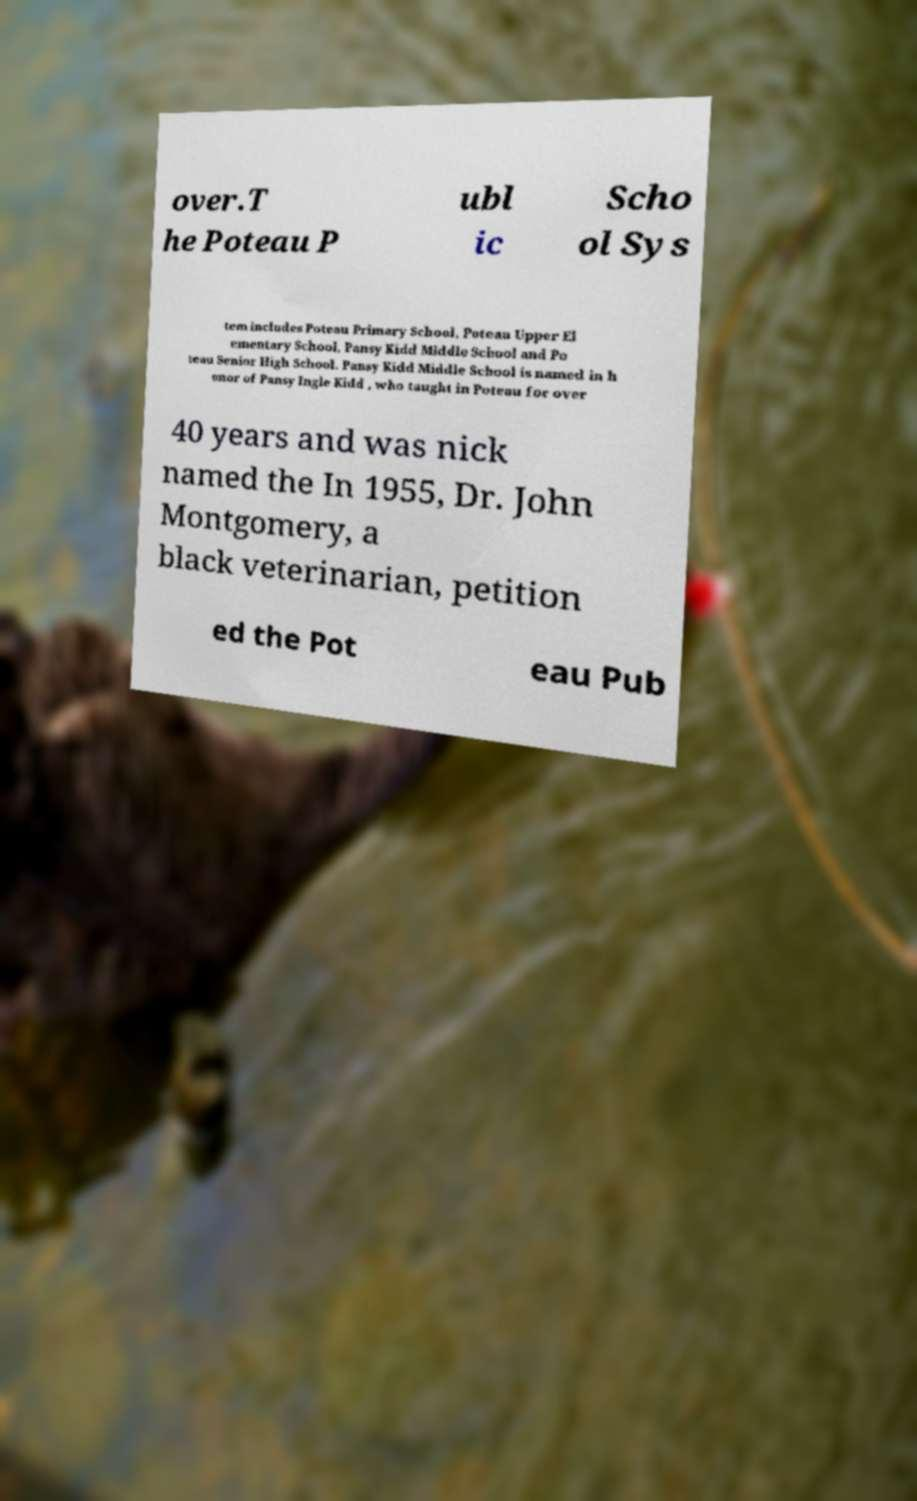I need the written content from this picture converted into text. Can you do that? over.T he Poteau P ubl ic Scho ol Sys tem includes Poteau Primary School, Poteau Upper El ementary School, Pansy Kidd Middle School and Po teau Senior High School. Pansy Kidd Middle School is named in h onor of Pansy Ingle Kidd , who taught in Poteau for over 40 years and was nick named the In 1955, Dr. John Montgomery, a black veterinarian, petition ed the Pot eau Pub 